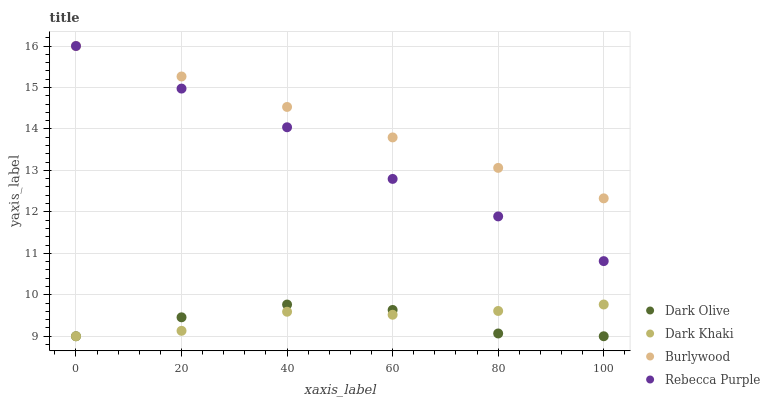Does Dark Olive have the minimum area under the curve?
Answer yes or no. Yes. Does Burlywood have the maximum area under the curve?
Answer yes or no. Yes. Does Burlywood have the minimum area under the curve?
Answer yes or no. No. Does Dark Olive have the maximum area under the curve?
Answer yes or no. No. Is Burlywood the smoothest?
Answer yes or no. Yes. Is Dark Olive the roughest?
Answer yes or no. Yes. Is Dark Olive the smoothest?
Answer yes or no. No. Is Burlywood the roughest?
Answer yes or no. No. Does Dark Khaki have the lowest value?
Answer yes or no. Yes. Does Burlywood have the lowest value?
Answer yes or no. No. Does Rebecca Purple have the highest value?
Answer yes or no. Yes. Does Dark Olive have the highest value?
Answer yes or no. No. Is Dark Khaki less than Burlywood?
Answer yes or no. Yes. Is Rebecca Purple greater than Dark Khaki?
Answer yes or no. Yes. Does Rebecca Purple intersect Burlywood?
Answer yes or no. Yes. Is Rebecca Purple less than Burlywood?
Answer yes or no. No. Is Rebecca Purple greater than Burlywood?
Answer yes or no. No. Does Dark Khaki intersect Burlywood?
Answer yes or no. No. 